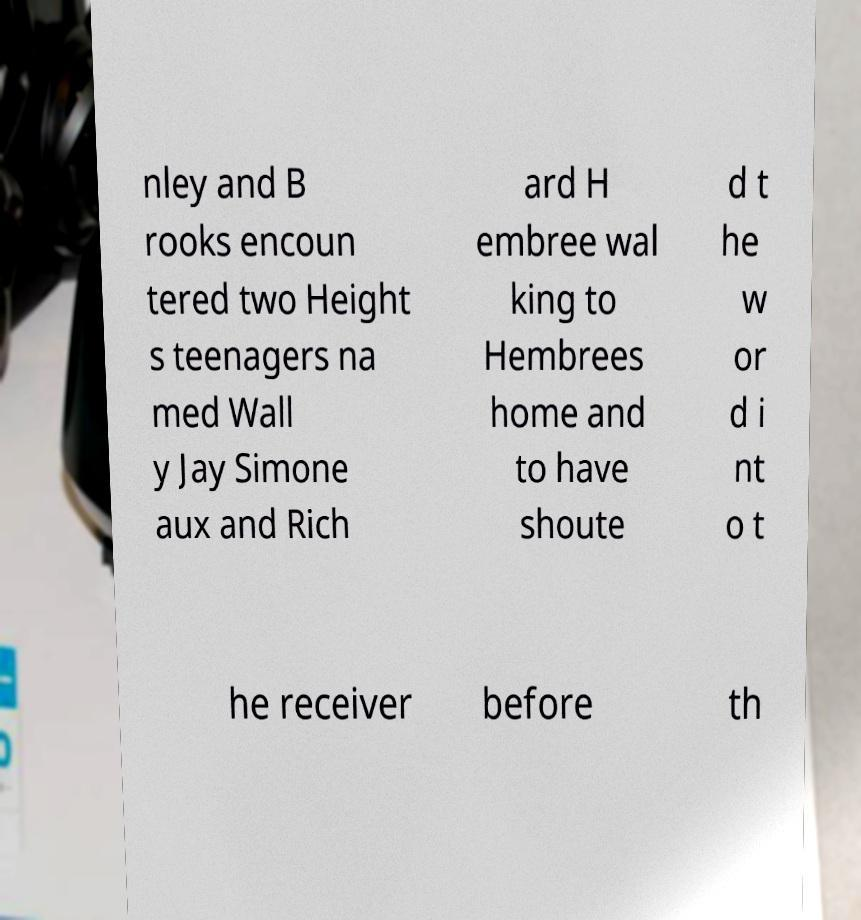Could you extract and type out the text from this image? nley and B rooks encoun tered two Height s teenagers na med Wall y Jay Simone aux and Rich ard H embree wal king to Hembrees home and to have shoute d t he w or d i nt o t he receiver before th 